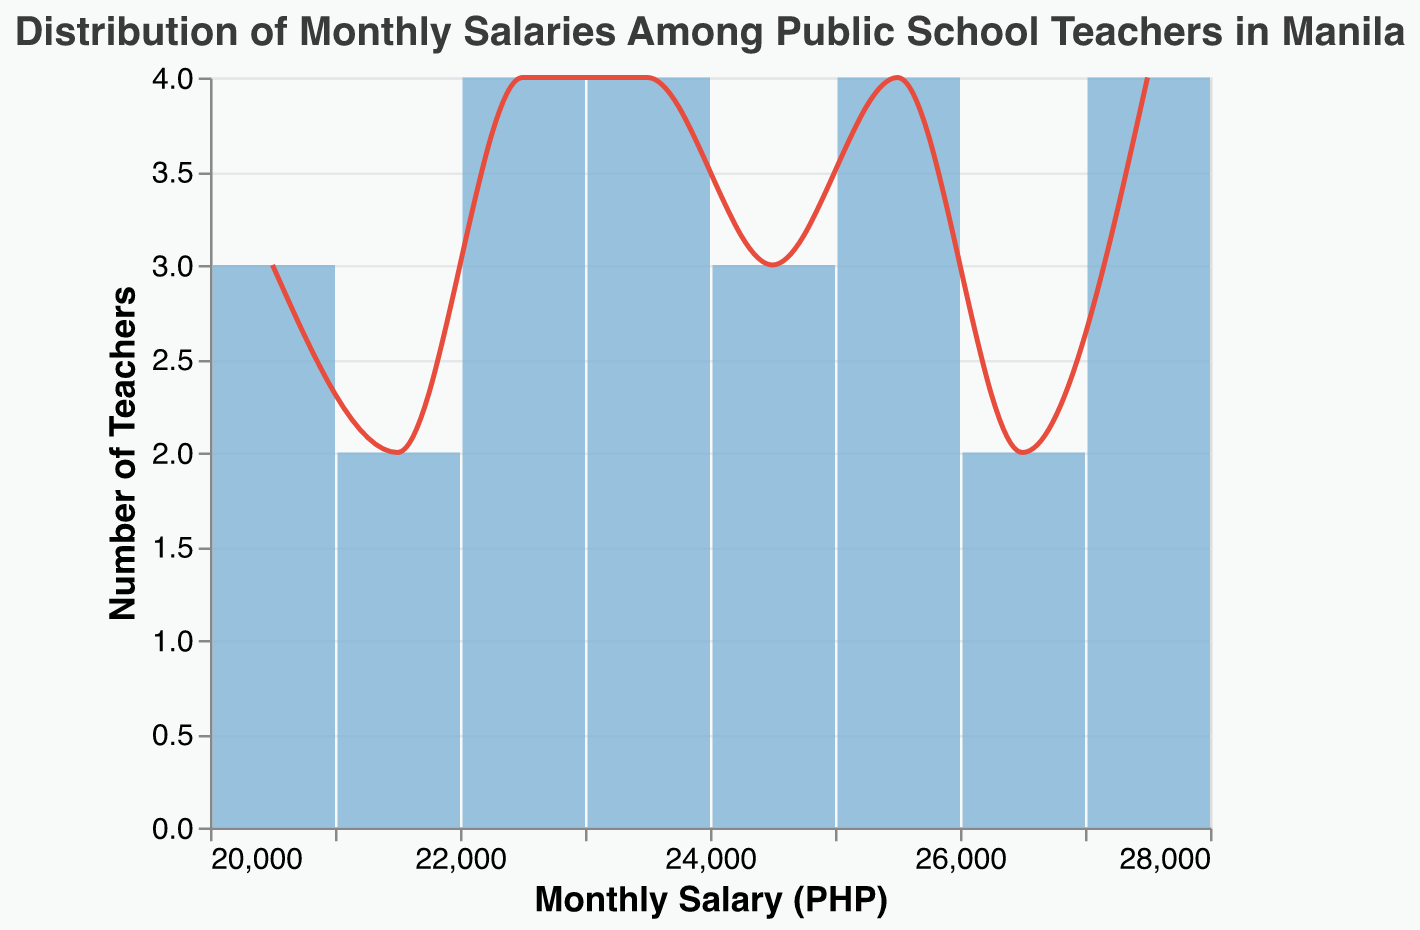What's the title of the plot? The title of the plot is displayed at the top center of the figure. It is written in a larger font size and different color compared to other elements, making it easy to spot.
Answer: Distribution of Monthly Salaries Among Public School Teachers in Manila What is the range of monthly salaries shown in the plot? The x-axis represents the monthly salaries. The salaries range from the lowest visible value to the highest.
Answer: 20000 to 28000 PHP How many teachers have a monthly salary of 25000 PHP? The bars in the plot show the number of teachers for each salary range. The bar at 25000 PHP indicates the count by its height.
Answer: 4 Which salary range has the most number of teachers? Look for the tallest bar in the plot. The x-axis label beneath this bar will show the salary range with the most teachers.
Answer: 22000-23000 PHP How does the number of teachers change from 20000 PHP to 21000 PHP? Compare the heights of the bars at 20000 PHP and 21000 PHP to see the difference in number of teachers.
Answer: It decreases What is the primary color used for the bars in the figure? The figure's bars are all shaded in a specific color. Identify this color.
Answer: Light blue Which salary range shows an abrupt increase or peak in the number of teachers? The line mark helps identify any peaks by looking for sharp upward movements. Locate where the line jumps significantly.
Answer: 22000-23000 PHP Is there any salary range with no teachers? Inspect the plot to find any gaps in bars where the count is zero.
Answer: No What's the approximate number of teachers within the 20000-21000 PHP salary range? Sum the heights of the bars between 20000 and 21000 PHP. Each bar height represents the teacher count.
Answer: 3 What's the overall trend in the distribution of teacher salaries? Observe the pattern formed by the bars and the line to determine whether it increases, decreases, or stays constant across the salary ranges.
Answer: Varied with peaks around 22000-23000 and 25000-26000 PHP 